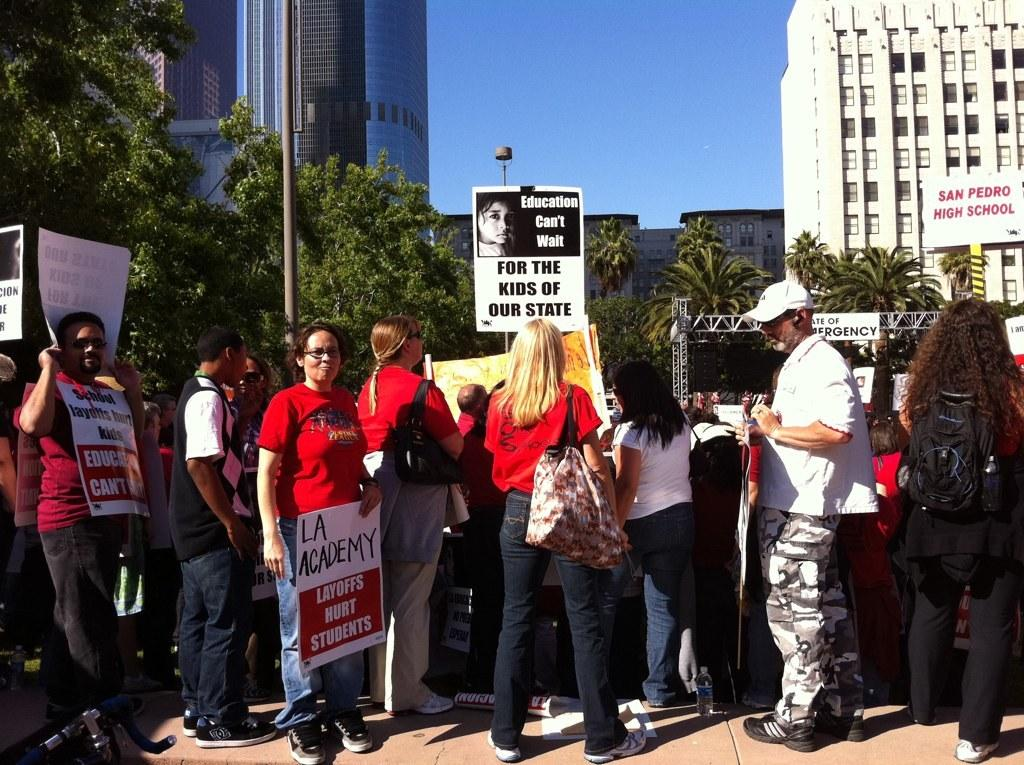How many people are in the image? There is a group of people in the image, but the exact number is not specified. What are the people holding in the image? The people are holding bags and banners in the image. What can be seen in the background of the image? There are pillars, trees, and buildings in the background of the image. What color is the finger on the shirt in the image? There is no finger or shirt present in the image. 